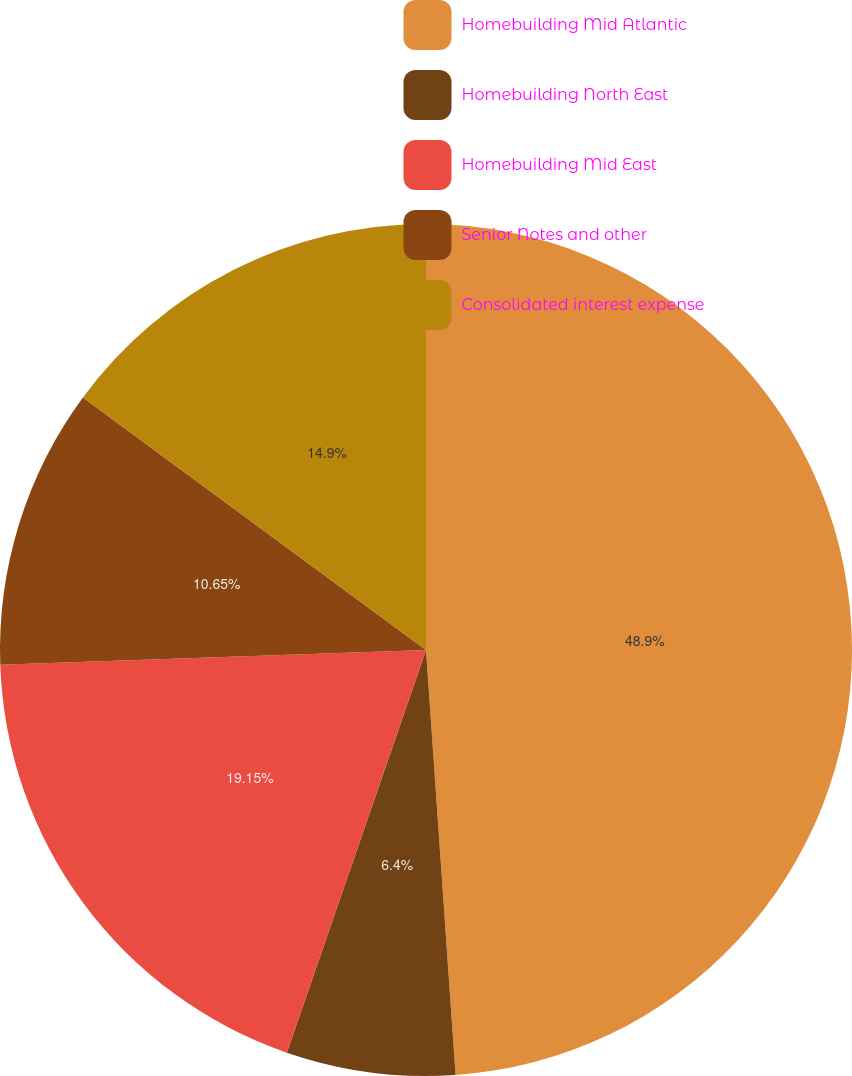Convert chart. <chart><loc_0><loc_0><loc_500><loc_500><pie_chart><fcel>Homebuilding Mid Atlantic<fcel>Homebuilding North East<fcel>Homebuilding Mid East<fcel>Senior Notes and other<fcel>Consolidated interest expense<nl><fcel>48.89%<fcel>6.4%<fcel>19.15%<fcel>10.65%<fcel>14.9%<nl></chart> 